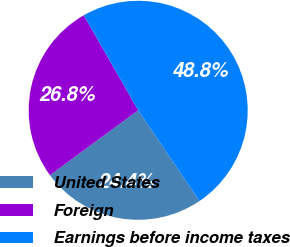<chart> <loc_0><loc_0><loc_500><loc_500><pie_chart><fcel>United States<fcel>Foreign<fcel>Earnings before income taxes<nl><fcel>24.37%<fcel>26.82%<fcel>48.81%<nl></chart> 